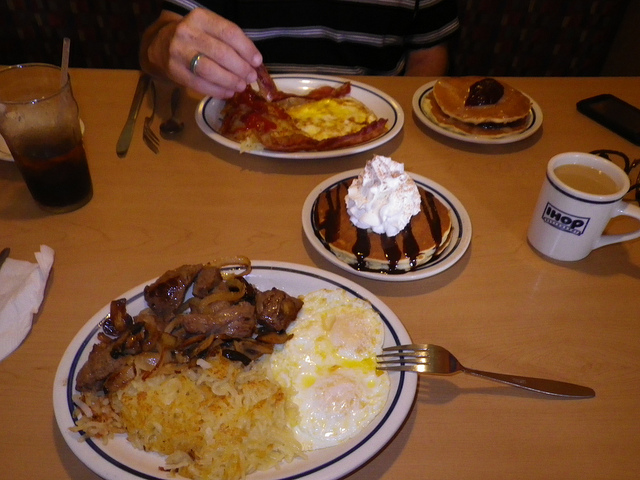<image>Where is the cantaloupe? There is no cantaloupe in the image. However, it could potentially be in the refrigerator or kitchen. Where is the cantaloupe? There is no cantaloupe in the image. 